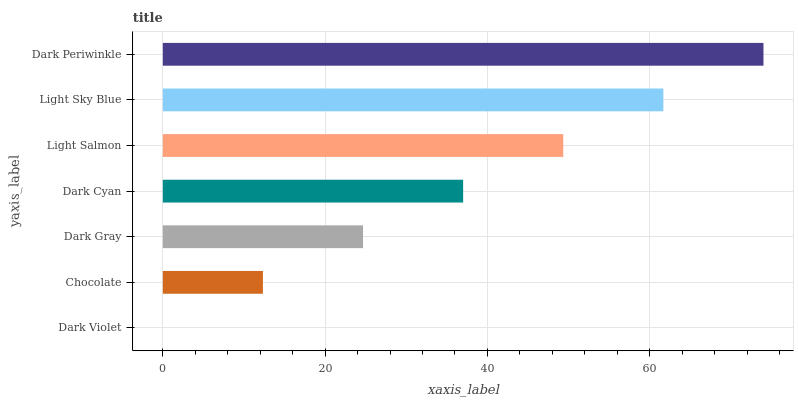Is Dark Violet the minimum?
Answer yes or no. Yes. Is Dark Periwinkle the maximum?
Answer yes or no. Yes. Is Chocolate the minimum?
Answer yes or no. No. Is Chocolate the maximum?
Answer yes or no. No. Is Chocolate greater than Dark Violet?
Answer yes or no. Yes. Is Dark Violet less than Chocolate?
Answer yes or no. Yes. Is Dark Violet greater than Chocolate?
Answer yes or no. No. Is Chocolate less than Dark Violet?
Answer yes or no. No. Is Dark Cyan the high median?
Answer yes or no. Yes. Is Dark Cyan the low median?
Answer yes or no. Yes. Is Dark Violet the high median?
Answer yes or no. No. Is Light Sky Blue the low median?
Answer yes or no. No. 